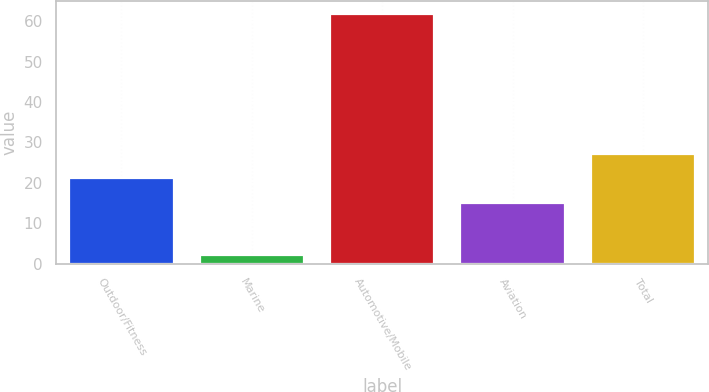Convert chart to OTSL. <chart><loc_0><loc_0><loc_500><loc_500><bar_chart><fcel>Outdoor/Fitness<fcel>Marine<fcel>Automotive/Mobile<fcel>Aviation<fcel>Total<nl><fcel>21.08<fcel>2.1<fcel>61.9<fcel>15.1<fcel>27.06<nl></chart> 